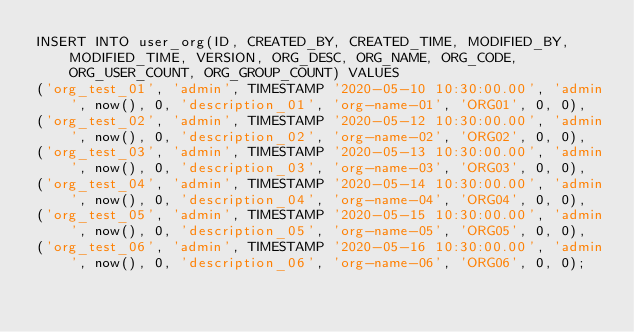<code> <loc_0><loc_0><loc_500><loc_500><_SQL_>INSERT INTO user_org(ID, CREATED_BY, CREATED_TIME, MODIFIED_BY, MODIFIED_TIME, VERSION, ORG_DESC, ORG_NAME, ORG_CODE, ORG_USER_COUNT, ORG_GROUP_COUNT) VALUES
('org_test_01', 'admin', TIMESTAMP '2020-05-10 10:30:00.00', 'admin', now(), 0, 'description_01', 'org-name-01', 'ORG01', 0, 0),
('org_test_02', 'admin', TIMESTAMP '2020-05-12 10:30:00.00', 'admin', now(), 0, 'description_02', 'org-name-02', 'ORG02', 0, 0),
('org_test_03', 'admin', TIMESTAMP '2020-05-13 10:30:00.00', 'admin', now(), 0, 'description_03', 'org-name-03', 'ORG03', 0, 0),
('org_test_04', 'admin', TIMESTAMP '2020-05-14 10:30:00.00', 'admin', now(), 0, 'description_04', 'org-name-04', 'ORG04', 0, 0),
('org_test_05', 'admin', TIMESTAMP '2020-05-15 10:30:00.00', 'admin', now(), 0, 'description_05', 'org-name-05', 'ORG05', 0, 0),
('org_test_06', 'admin', TIMESTAMP '2020-05-16 10:30:00.00', 'admin', now(), 0, 'description_06', 'org-name-06', 'ORG06', 0, 0);
</code> 